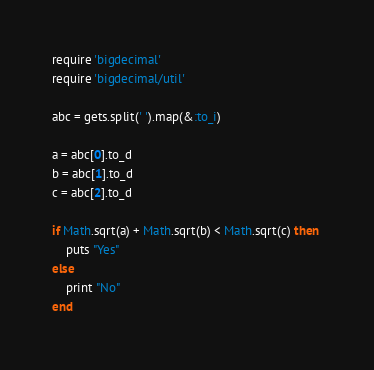Convert code to text. <code><loc_0><loc_0><loc_500><loc_500><_Ruby_>require 'bigdecimal'
require 'bigdecimal/util'

abc = gets.split(' ').map(&:to_i)

a = abc[0].to_d
b = abc[1].to_d
c = abc[2].to_d

if Math.sqrt(a) + Math.sqrt(b) < Math.sqrt(c) then 
    puts "Yes"
else
    print "No"
end</code> 